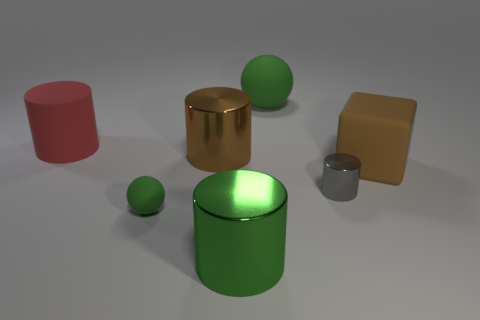Is there a tiny blue metallic cylinder?
Offer a terse response. No. The other sphere that is the same material as the big green sphere is what size?
Give a very brief answer. Small. The metal object that is in front of the green rubber ball in front of the brown object in front of the big brown shiny thing is what shape?
Provide a short and direct response. Cylinder. Is the number of brown cubes on the right side of the brown cube the same as the number of big yellow cylinders?
Give a very brief answer. Yes. There is a cylinder that is the same color as the large rubber block; what size is it?
Offer a terse response. Large. Is the large green matte object the same shape as the small green thing?
Provide a short and direct response. Yes. How many things are either small metallic cylinders that are in front of the large brown metallic object or gray cylinders?
Keep it short and to the point. 1. Are there the same number of large green shiny cylinders that are behind the brown metallic thing and big cubes behind the big rubber cylinder?
Your response must be concise. Yes. How many other things are there of the same shape as the tiny green object?
Provide a succinct answer. 1. There is a brown object to the left of the big green rubber object; does it have the same size as the green ball in front of the tiny gray metallic object?
Keep it short and to the point. No. 